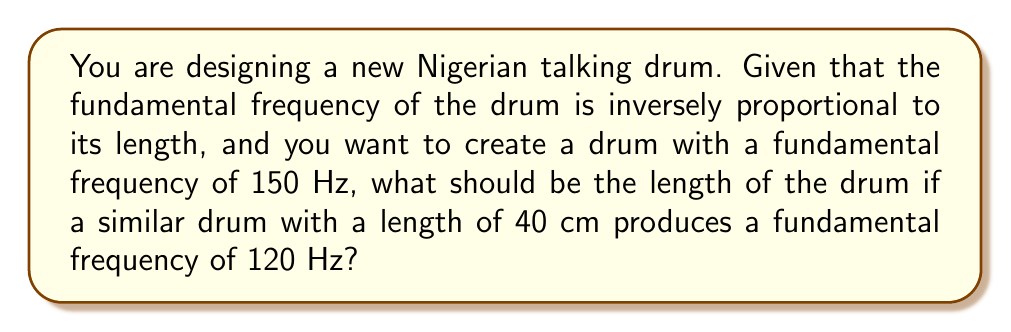Give your solution to this math problem. Let's approach this step-by-step:

1) We know that the fundamental frequency ($f$) is inversely proportional to the length ($L$) of the drum. This can be expressed mathematically as:

   $f \propto \frac{1}{L}$

2) We can write this as an equation with a constant $k$:

   $f = \frac{k}{L}$

3) We have two sets of values:
   - For the existing drum: $f_1 = 120$ Hz, $L_1 = 40$ cm
   - For the new drum: $f_2 = 150$ Hz, $L_2 = ?$ (what we're solving for)

4) We can set up two equations:

   $120 = \frac{k}{40}$
   $150 = \frac{k}{L_2}$

5) From the first equation, we can find $k$:

   $k = 120 \times 40 = 4800$

6) Now we can use this in the second equation:

   $150 = \frac{4800}{L_2}$

7) Solve for $L_2$:

   $L_2 = \frac{4800}{150} = 32$ cm

Therefore, the new drum should be 32 cm long to produce a fundamental frequency of 150 Hz.
Answer: 32 cm 